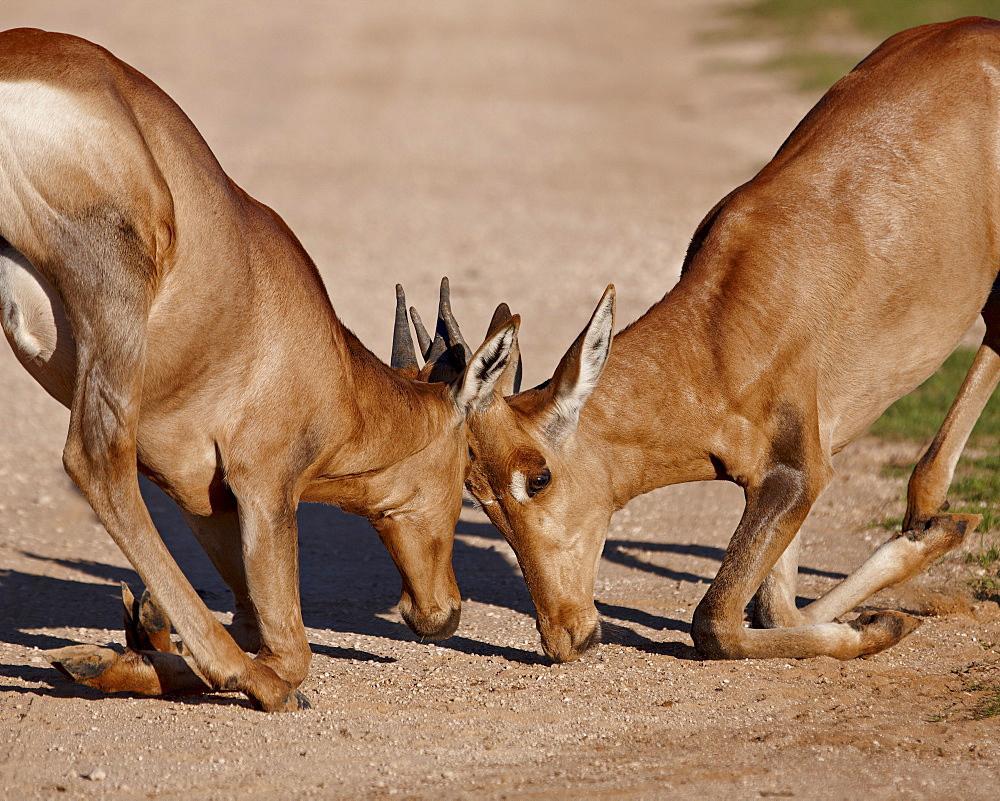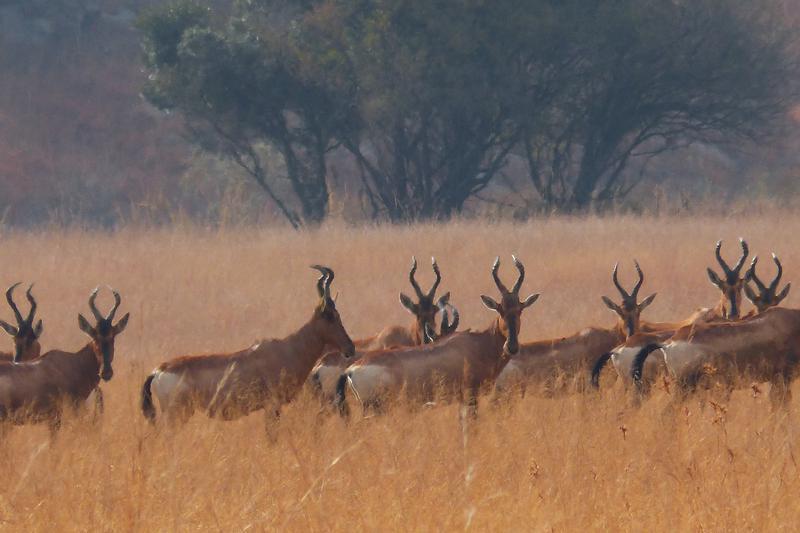The first image is the image on the left, the second image is the image on the right. Considering the images on both sides, is "There are at most two hartebeests." valid? Answer yes or no. No. The first image is the image on the left, the second image is the image on the right. For the images shown, is this caption "At least one antelope has its legs up in the air." true? Answer yes or no. No. 